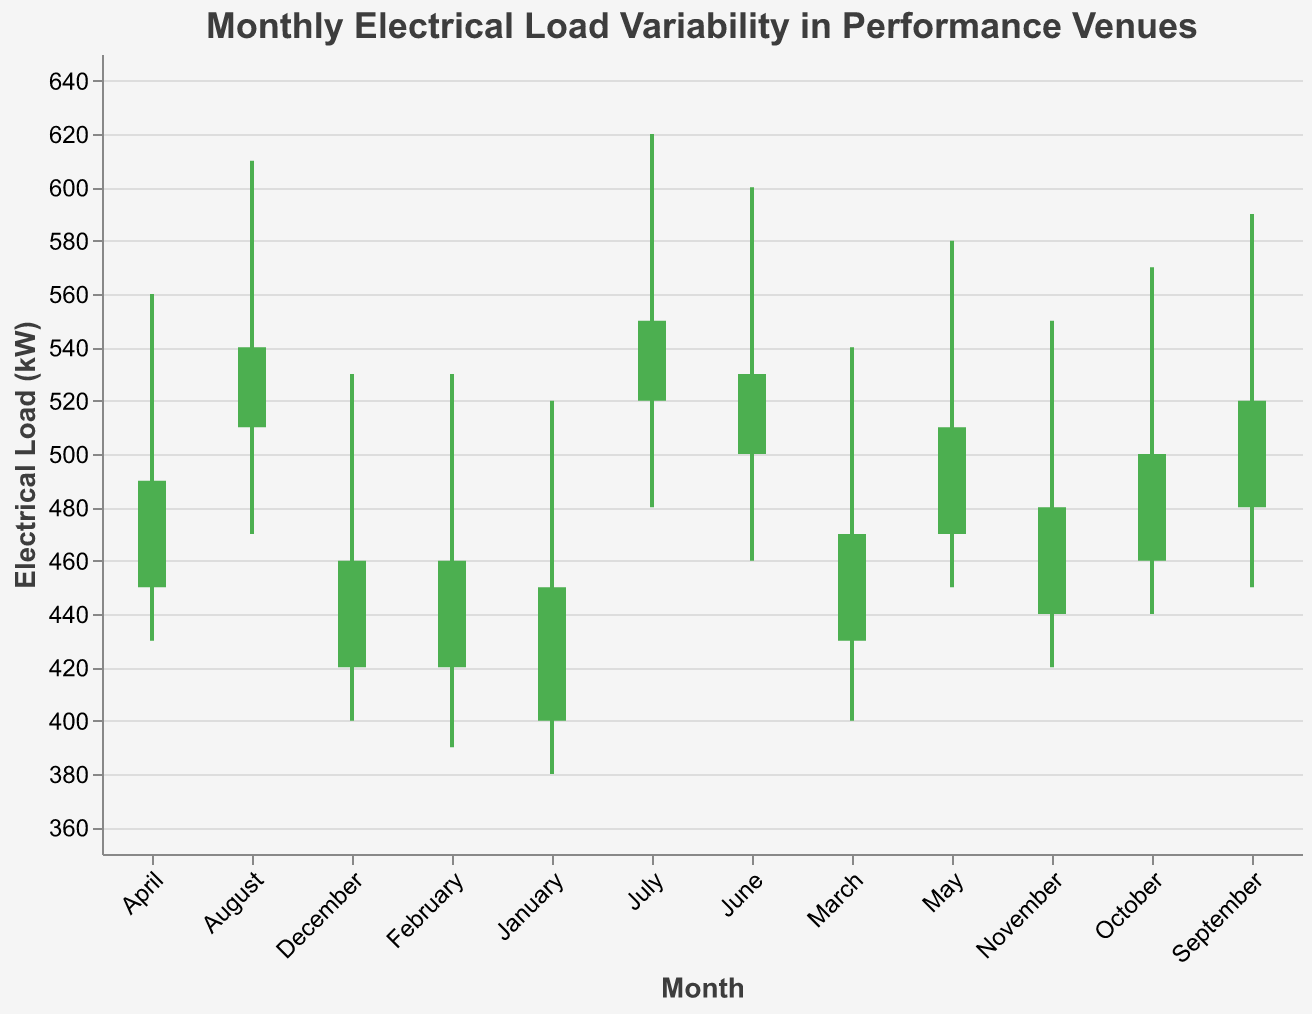What's the title of the plot? The title is located at the top of the plot. It is visually larger in font size and distinct in color.
Answer: Monthly Electrical Load Variability in Performance Venues What are the highest and lowest electrical loads recorded in December? For December, the highest value is represented by the "High" of 530 kW, and the lowest value is represented by the "Low" of 400 kW.
Answer: 530 kW, 400 kW Which month has the highest peak electrical load and what is that value? The month with the highest peak electrical load is identified by the highest "High" value. In the plot, the highest "High" value is 620 kW in July.
Answer: July, 620 kW What is the average "Close" value across the months? Add up all the "Close" values and then divide by the number of months (12). The sum is 450 + 460 + 470 + 490 + 510 + 530 + 550 + 540 + 520 + 500 + 480 + 460 = 5960. The average is 5960 / 12 = 496.67.
Answer: 496.67 kW Which month showed a decrease in electrical load from opening to closing values? Months showing a decrease in load will have a "Close" value less than an "Open" value. Based on the plot, August, September, October, and November show such a trend.
Answer: August, September, October, November How does the variability in electrical load in May compare to that in June? Variability is reflected in the range between "Low" and "High" values. For May, it's 580 - 450 = 130; for June, it's 600 - 460 = 140. June has higher variability than May.
Answer: June has higher variability Which months fall within an electrical load range of 440 kW to 480 kW at closing time? By looking at the "Close" values that fall within the 440-480 kW range, we find January (450), February (460), November (480), and December (460).
Answer: January, February, November, December During which month does the electrical load equal the maximum "High" value recorded for that month? The "High" value for each month can be compared, and the maximum "High" value of 620 kW in July corresponds to that month's electrical load.
Answer: July 